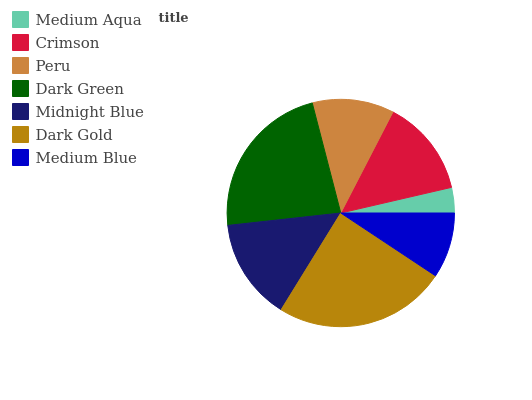Is Medium Aqua the minimum?
Answer yes or no. Yes. Is Dark Gold the maximum?
Answer yes or no. Yes. Is Crimson the minimum?
Answer yes or no. No. Is Crimson the maximum?
Answer yes or no. No. Is Crimson greater than Medium Aqua?
Answer yes or no. Yes. Is Medium Aqua less than Crimson?
Answer yes or no. Yes. Is Medium Aqua greater than Crimson?
Answer yes or no. No. Is Crimson less than Medium Aqua?
Answer yes or no. No. Is Crimson the high median?
Answer yes or no. Yes. Is Crimson the low median?
Answer yes or no. Yes. Is Medium Aqua the high median?
Answer yes or no. No. Is Peru the low median?
Answer yes or no. No. 